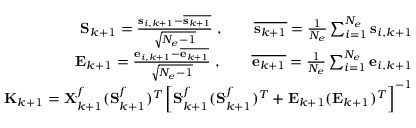Convert formula to latex. <formula><loc_0><loc_0><loc_500><loc_500>\begin{array} { r } { S _ { k + 1 } = \frac { s _ { i , k + 1 } - \overline { { s _ { k + 1 } } } } { \sqrt { N _ { e } - 1 } } \, , \quad \overline { { s _ { k + 1 } } } = \frac { 1 } { N _ { e } } \sum _ { i = 1 } ^ { N _ { e } } s _ { i , k + 1 } } \\ { E _ { k + 1 } = \frac { e _ { i , k + 1 } - \overline { { e _ { k + 1 } } } } { \sqrt { N _ { e } - 1 } } \, , \quad \overline { { e _ { k + 1 } } } = \frac { 1 } { N _ { e } } \sum _ { i = 1 } ^ { N _ { e } } e _ { i , k + 1 } } \\ { K _ { k + 1 } = X _ { k + 1 } ^ { f } ( S _ { k + 1 } ^ { f } ) ^ { T } \left [ S _ { k + 1 } ^ { f } ( S _ { k + 1 } ^ { f } ) ^ { T } + E _ { k + 1 } ( E _ { k + 1 } ) ^ { T } \right ] ^ { - 1 } } \end{array}</formula> 